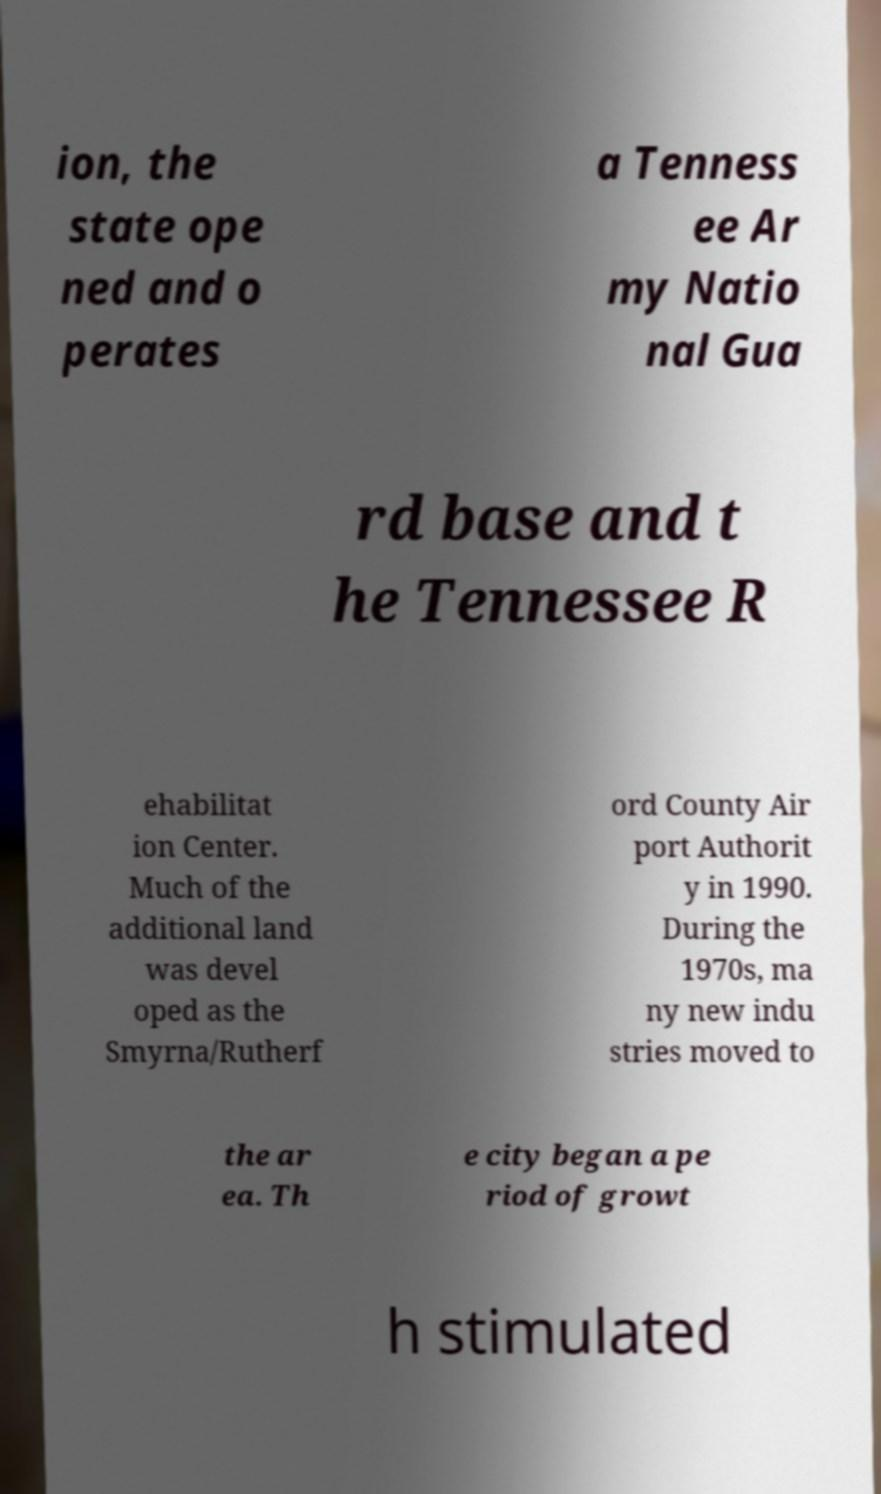There's text embedded in this image that I need extracted. Can you transcribe it verbatim? ion, the state ope ned and o perates a Tenness ee Ar my Natio nal Gua rd base and t he Tennessee R ehabilitat ion Center. Much of the additional land was devel oped as the Smyrna/Rutherf ord County Air port Authorit y in 1990. During the 1970s, ma ny new indu stries moved to the ar ea. Th e city began a pe riod of growt h stimulated 